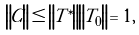Convert formula to latex. <formula><loc_0><loc_0><loc_500><loc_500>\left \| C \right \| \leq \left \| T ^ { \ast } \right \| \left \| T _ { 0 } \right \| = 1 ,</formula> 